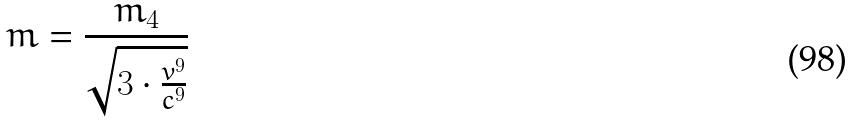<formula> <loc_0><loc_0><loc_500><loc_500>m = \frac { m _ { 4 } } { \sqrt { 3 \cdot \frac { v ^ { 9 } } { c ^ { 9 } } } }</formula> 